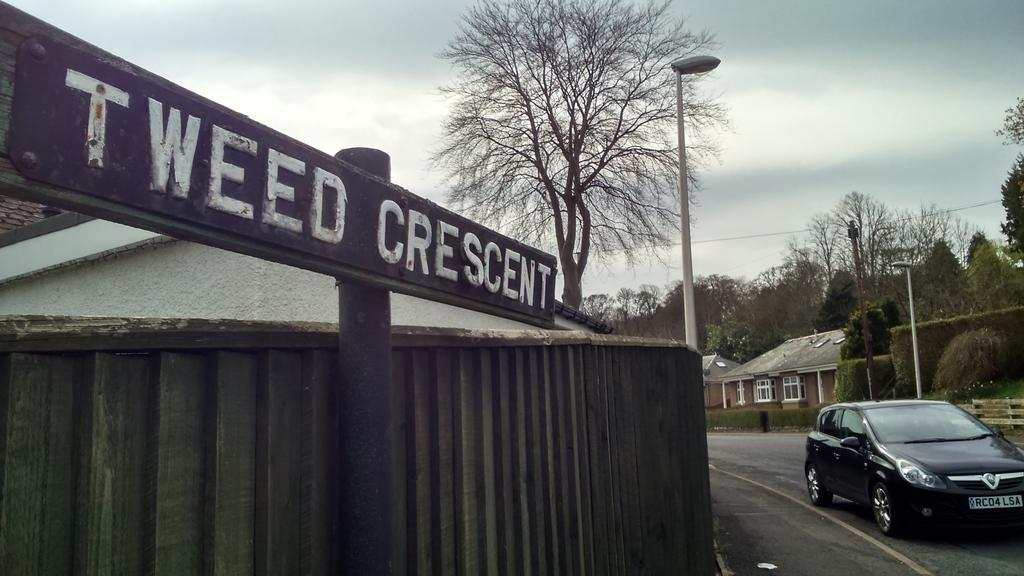What is the main subject of the image? The main subject of the image is a car. What is the car doing in the image? The car is moving on the road in the image. What can be seen in the background of the image? Trees, houses, pole lights, and a name board on a pole are visible in the background of the image. How would you describe the sky in the image? The sky in the image is blue and cloudy. What type of roof can be seen on the car in the image? There is no specific roof mentioned or visible in the image; we can only see the car moving on the road. What is the acoustics like in the car in the image? The image does not provide any information about the acoustics inside the car, as it only shows the car moving on the road. 